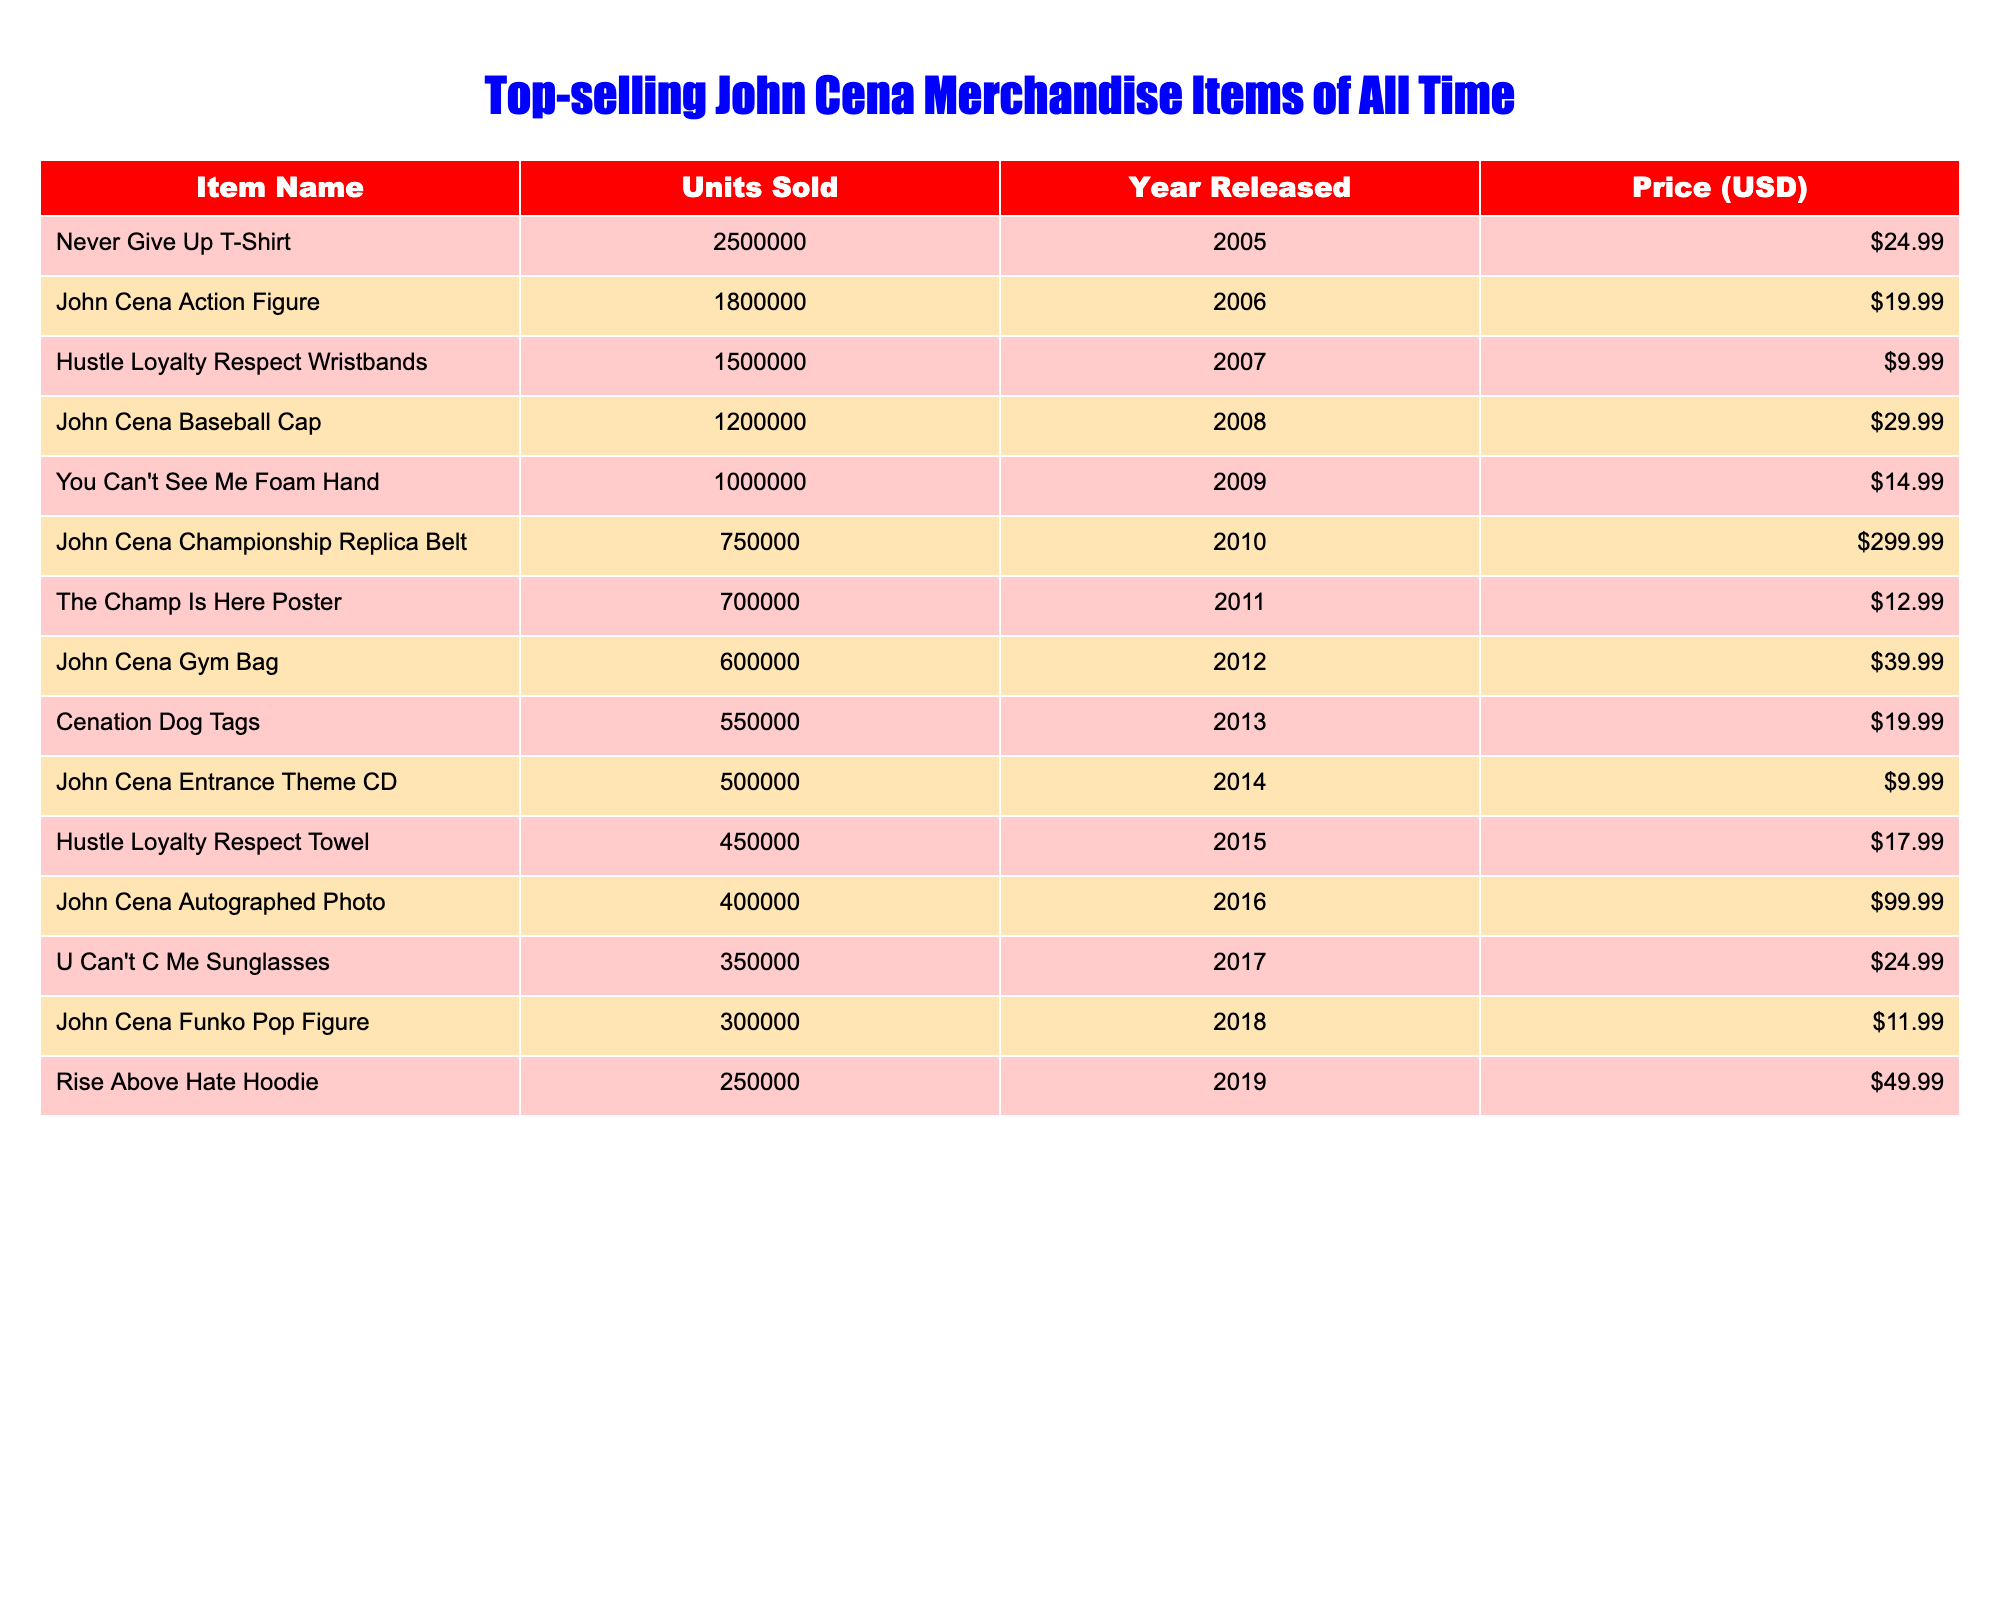What is the item with the highest number of units sold? The table shows the number of units sold for each item. The "Never Give Up" T-Shirt has the highest number at 2,500,000 units sold.
Answer: "Never Give Up" T-Shirt How many units were sold for John Cena's Action Figure? Referring to the table, the John Cena Action Figure sold 1,800,000 units.
Answer: 1,800,000 What is the total number of units sold for the top three merchandise items? Summing the units for the top three items: 2,500,000 (T-Shirt) + 1,800,000 (Action Figure) + 1,500,000 (Wristbands) results in 5,800,000 units sold in total.
Answer: 5,800,000 What year was the "Hustle Loyalty Respect Wristbands" released? The "Hustle Loyalty Respect Wristbands" are listed in the table, and they were released in 2007.
Answer: 2007 Is the price of the John Cena Gym Bag greater than $50? The price of the John Cena Gym Bag is $39.99, which is less than $50. Hence, the answer is no.
Answer: No Which item has the lowest sales and what is the number of units sold? Looking through the table, the item with the lowest sales is the “John Cena Funko Pop Figure” at 300,000 units sold.
Answer: John Cena Funko Pop Figure, 300,000 What is the average price of the top five selling merchandise items? The top five items are the T-Shirt, Action Figure, Wristbands, Baseball Cap, and Foam Hand. Their prices are $24.99, $19.99, $9.99, $29.99, and $14.99 respectively. The total price is $24.99 + $19.99 + $9.99 + $29.99 + $14.99 = $109.95. Dividing by 5 gives an average of $21.99.
Answer: $21.99 How many more units were sold of the "You Can't See Me" Foam Hand than the John Cena Championship Replica Belt? From the table, the Foam Hand sold 1,000,000 units while the Championship Belt sold 750,000 units. The difference is 1,000,000 - 750,000 = 250,000 units sold more for the Foam Hand.
Answer: 250,000 What percentage of total sales does the "Rise Above Hate" Hoodie represent among all items? The total units sold across all items is 10,050,000. The Hoodie sold 250,000 units. The percentage is (250,000 / 10,050,000) * 100 = approximately 2.49%.
Answer: 2.49% Which item was released most recently and how many units has it sold? The most recently released item is the "Rise Above Hate" Hoodie from 2019, which has sold 250,000 units.
Answer: "Rise Above Hate" Hoodie, 250,000 units 